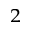<formula> <loc_0><loc_0><loc_500><loc_500>^ { 2 }</formula> 